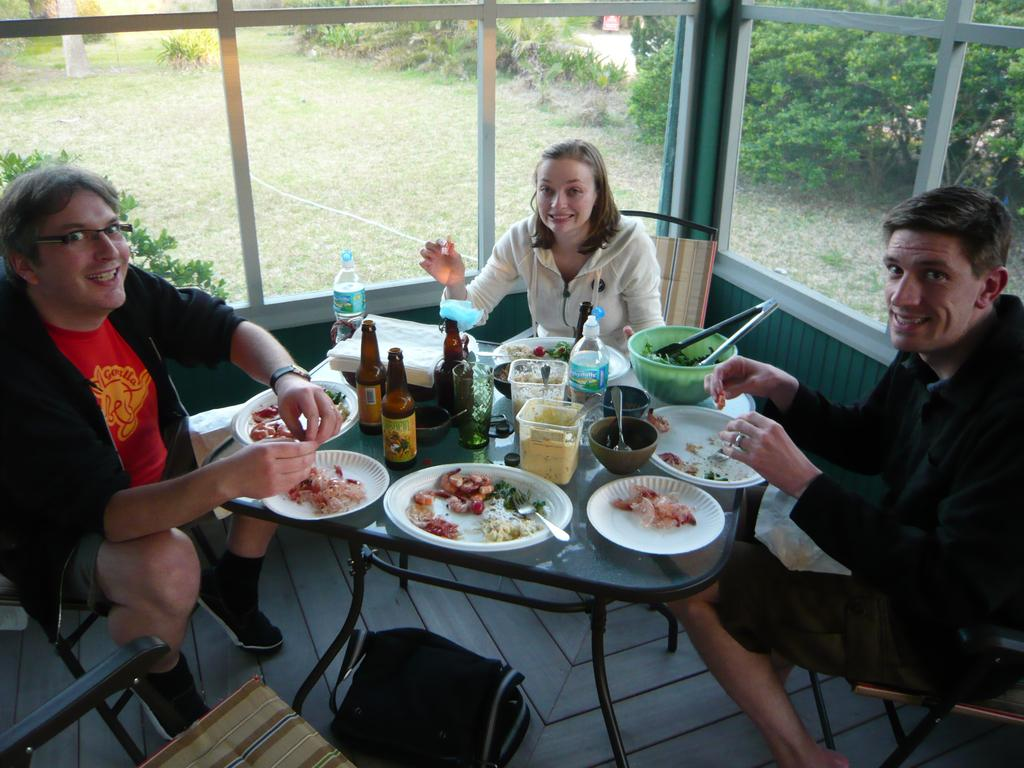How many people are sitting in the image? There are 3 people sitting on chairs in the image. What is present on the table in the image? There is a plate, a bowl, a spoon, and a tissue on the table in the image. What can be seen in the background of the image? There is a curtain and a window visible in the background. What color is the paint on the father's neck in the image? There is no father or paint present in the image. 